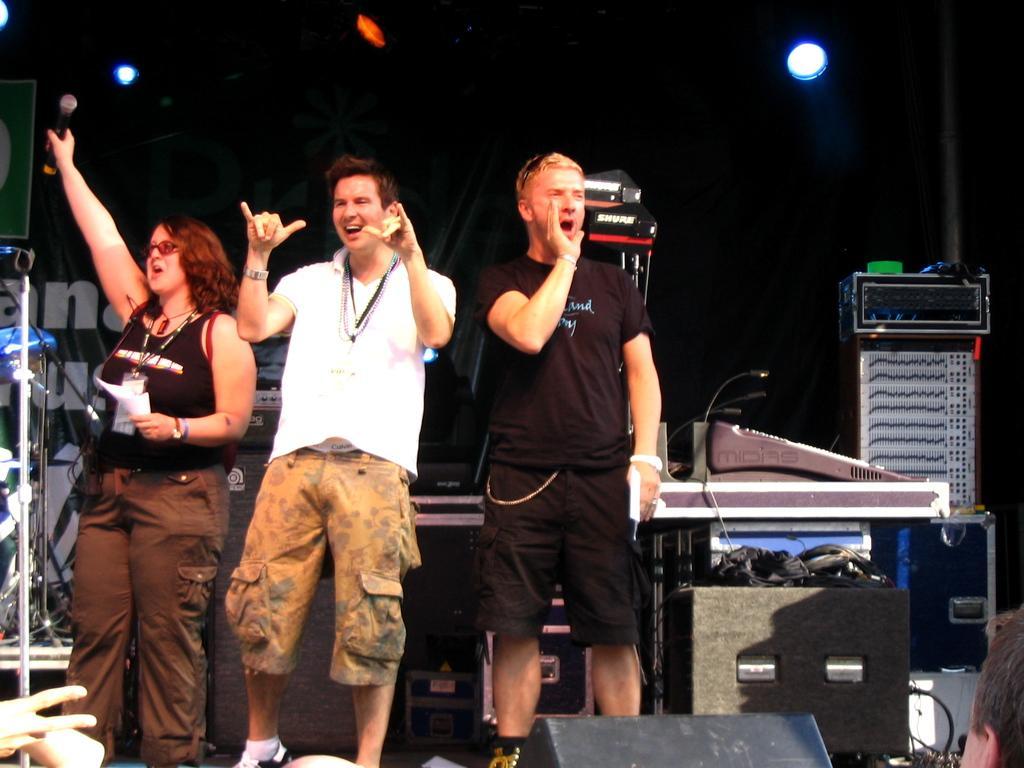Could you give a brief overview of what you see in this image? In this image there are three people standing, and they are screaming and one person is holding a mike and some papers. And at the bottom there are some persons, and there is some object at the bottom. And in the background there are some music systems, wires, poles, mikes and some other objects. At the top there are some lights and there is one board, on the board there is some text. 